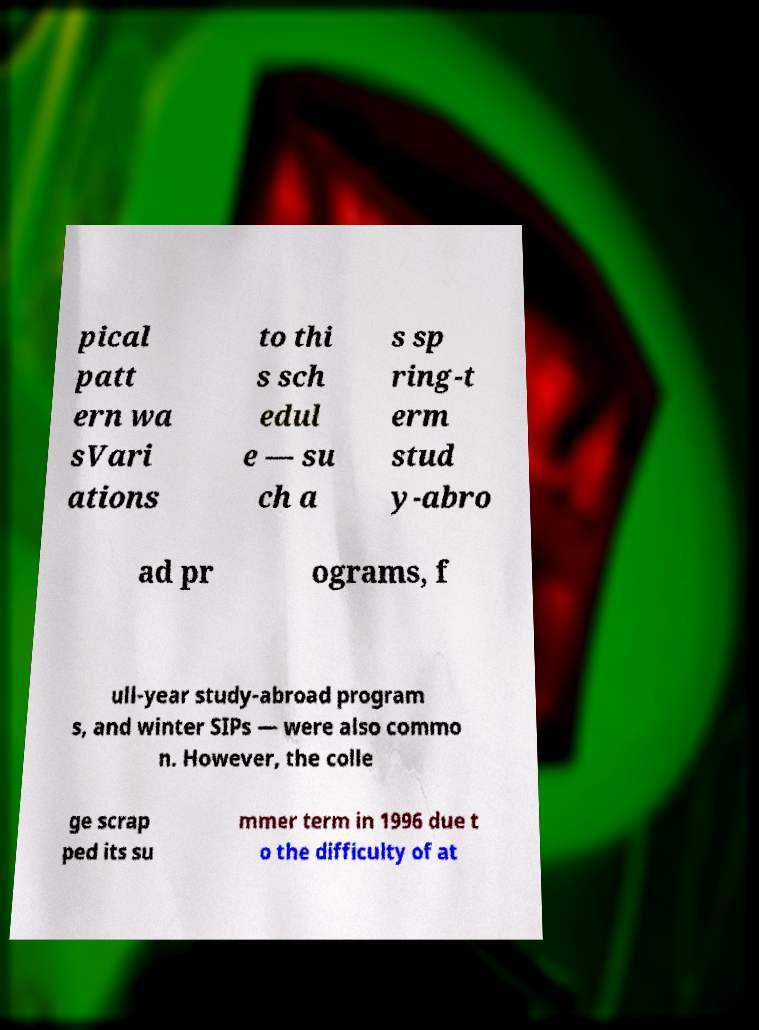Can you read and provide the text displayed in the image?This photo seems to have some interesting text. Can you extract and type it out for me? pical patt ern wa sVari ations to thi s sch edul e — su ch a s sp ring-t erm stud y-abro ad pr ograms, f ull-year study-abroad program s, and winter SIPs — were also commo n. However, the colle ge scrap ped its su mmer term in 1996 due t o the difficulty of at 